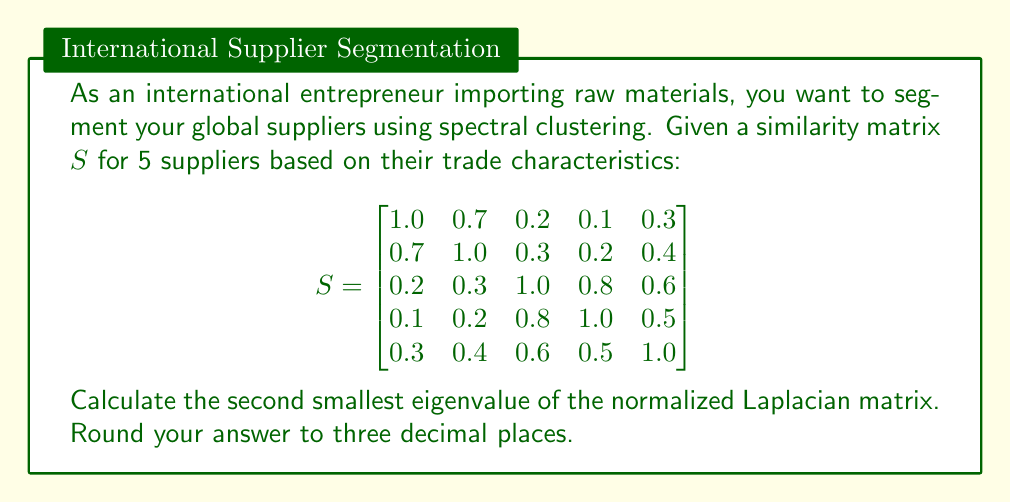Solve this math problem. To solve this problem, we'll follow these steps:

1) First, we need to construct the degree matrix $D$. The degree of each node is the sum of its similarities:
   $$D = \text{diag}(2.3, 2.6, 2.9, 2.6, 2.8)$$

2) Now we can construct the normalized Laplacian matrix $L_{\text{sym}}$:
   $$L_{\text{sym}} = I - D^{-1/2}SD^{-1/2}$$

3) Let's calculate $D^{-1/2}$:
   $$D^{-1/2} = \text{diag}(1/\sqrt{2.3}, 1/\sqrt{2.6}, 1/\sqrt{2.9}, 1/\sqrt{2.6}, 1/\sqrt{2.8})$$

4) Now we can calculate $L_{\text{sym}}$:
   $$L_{\text{sym}} = I - D^{-1/2}SD^{-1/2}$$

5) The resulting $L_{\text{sym}}$ matrix is:
   $$L_{\text{sym}} \approx \begin{bmatrix}
   0.5652 & -0.3293 & -0.0891 & -0.0471 & -0.1360 \\
   -0.3293 & 0.6154 & -0.1140 & -0.0801 & -0.1545 \\
   -0.0891 & -0.1140 & 0.6552 & -0.3839 & -0.2776 \\
   -0.0471 & -0.0801 & -0.3839 & 0.6154 & -0.1860 \\
   -0.1360 & -0.1545 & -0.2776 & -0.1860 & 0.6429
   \end{bmatrix}$$

6) We need to find the eigenvalues of this matrix. Using a numerical method or linear algebra software, we can calculate the eigenvalues:
   $$\lambda_1 \approx 0.000, \lambda_2 \approx 0.249, \lambda_3 \approx 0.435, \lambda_4 \approx 0.808, \lambda_5 \approx 1.508$$

7) The second smallest eigenvalue is $\lambda_2 \approx 0.249$.

8) Rounding to three decimal places, we get 0.249.
Answer: 0.249 